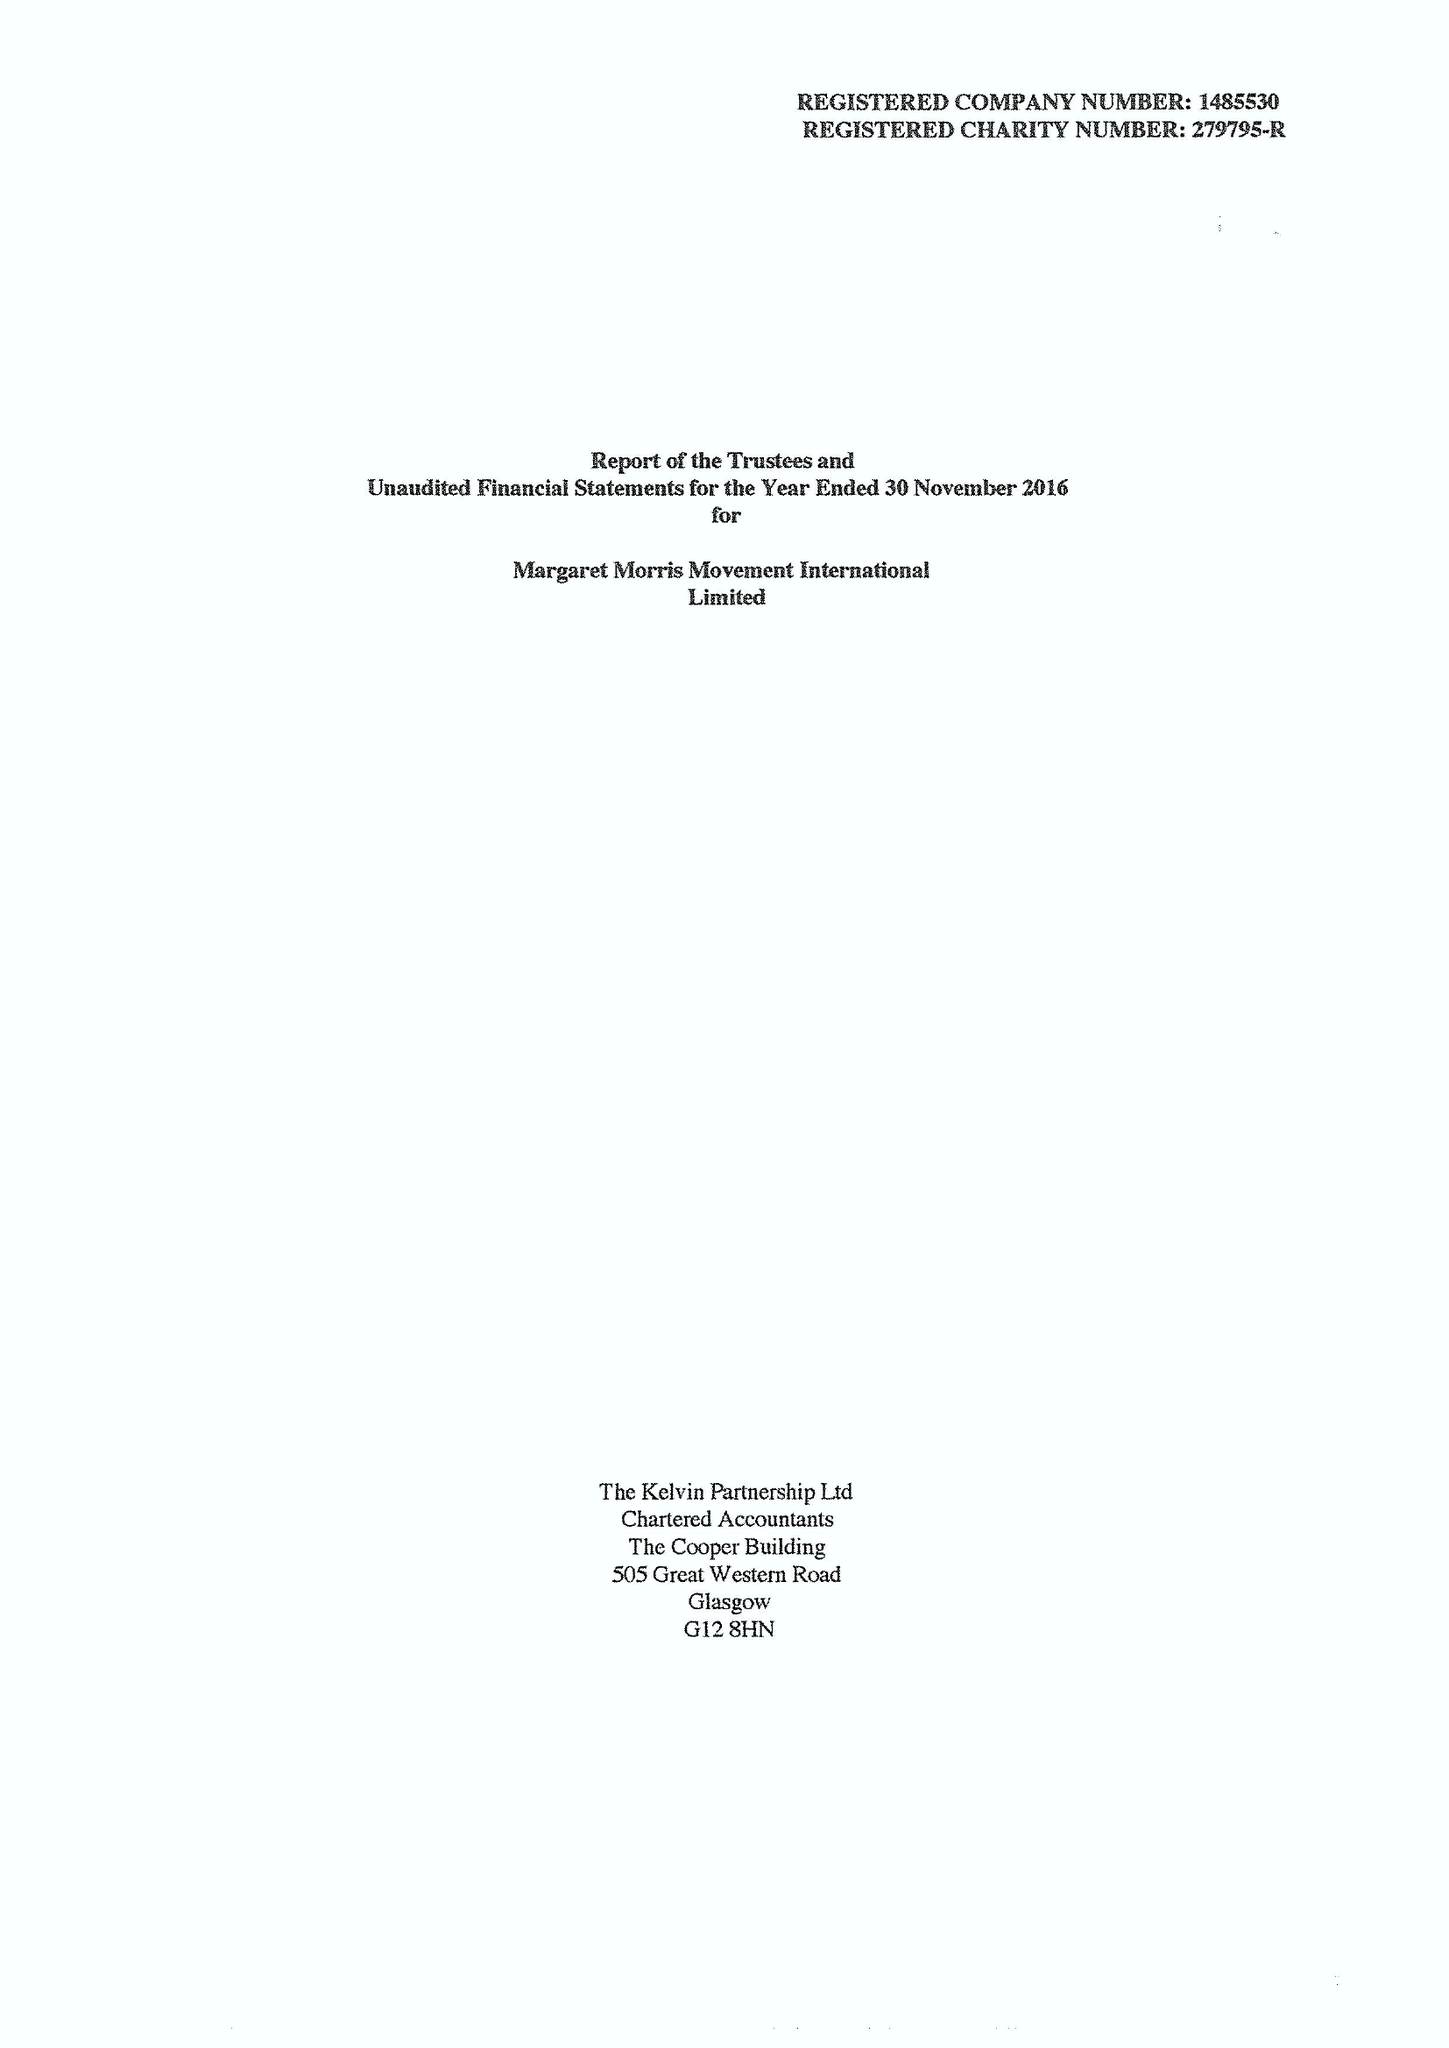What is the value for the address__street_line?
Answer the question using a single word or phrase. None 